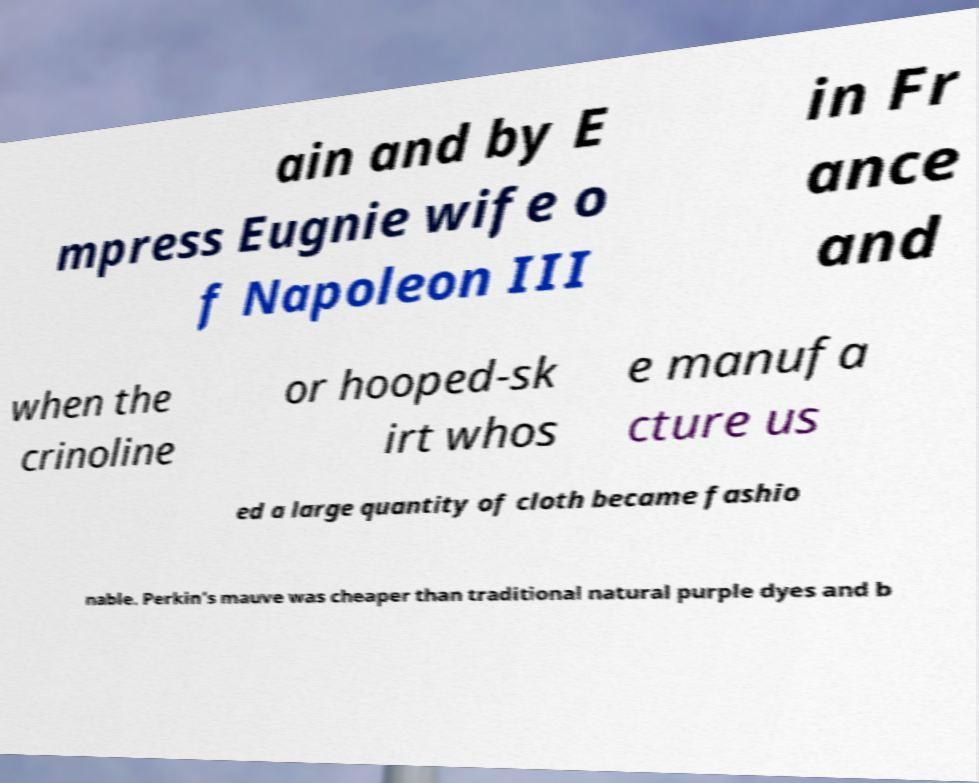Could you assist in decoding the text presented in this image and type it out clearly? ain and by E mpress Eugnie wife o f Napoleon III in Fr ance and when the crinoline or hooped-sk irt whos e manufa cture us ed a large quantity of cloth became fashio nable. Perkin’s mauve was cheaper than traditional natural purple dyes and b 